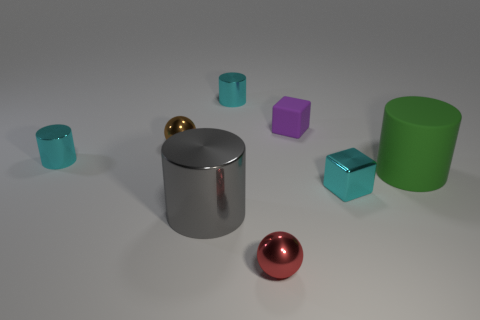Are there any blue blocks of the same size as the gray shiny thing?
Your answer should be compact. No. What number of shiny cubes are the same size as the gray shiny cylinder?
Offer a very short reply. 0. Does the metal cylinder that is to the right of the gray metal cylinder have the same size as the cyan thing that is on the right side of the purple matte block?
Your answer should be compact. Yes. What number of things are either tiny things or cyan metallic cylinders that are to the left of the gray cylinder?
Make the answer very short. 6. The matte cylinder has what color?
Provide a short and direct response. Green. The big object right of the red metal thing to the left of the small cube in front of the big green matte thing is made of what material?
Your response must be concise. Rubber. There is a gray cylinder that is the same material as the small red sphere; what is its size?
Provide a succinct answer. Large. Are there any small objects that have the same color as the shiny cube?
Keep it short and to the point. Yes. Does the brown shiny ball have the same size as the metal ball that is in front of the brown ball?
Offer a terse response. Yes. There is a small red ball that is in front of the tiny cyan shiny cylinder on the left side of the brown shiny sphere; what number of large green cylinders are to the left of it?
Your answer should be compact. 0. 